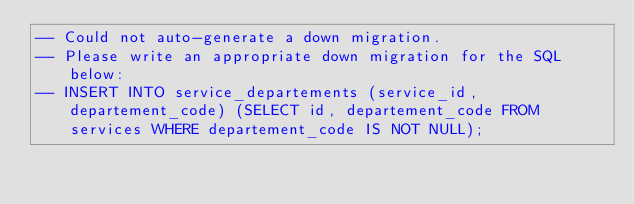Convert code to text. <code><loc_0><loc_0><loc_500><loc_500><_SQL_>-- Could not auto-generate a down migration.
-- Please write an appropriate down migration for the SQL below:
-- INSERT INTO service_departements (service_id, departement_code) (SELECT id, departement_code FROM services WHERE departement_code IS NOT NULL);
</code> 